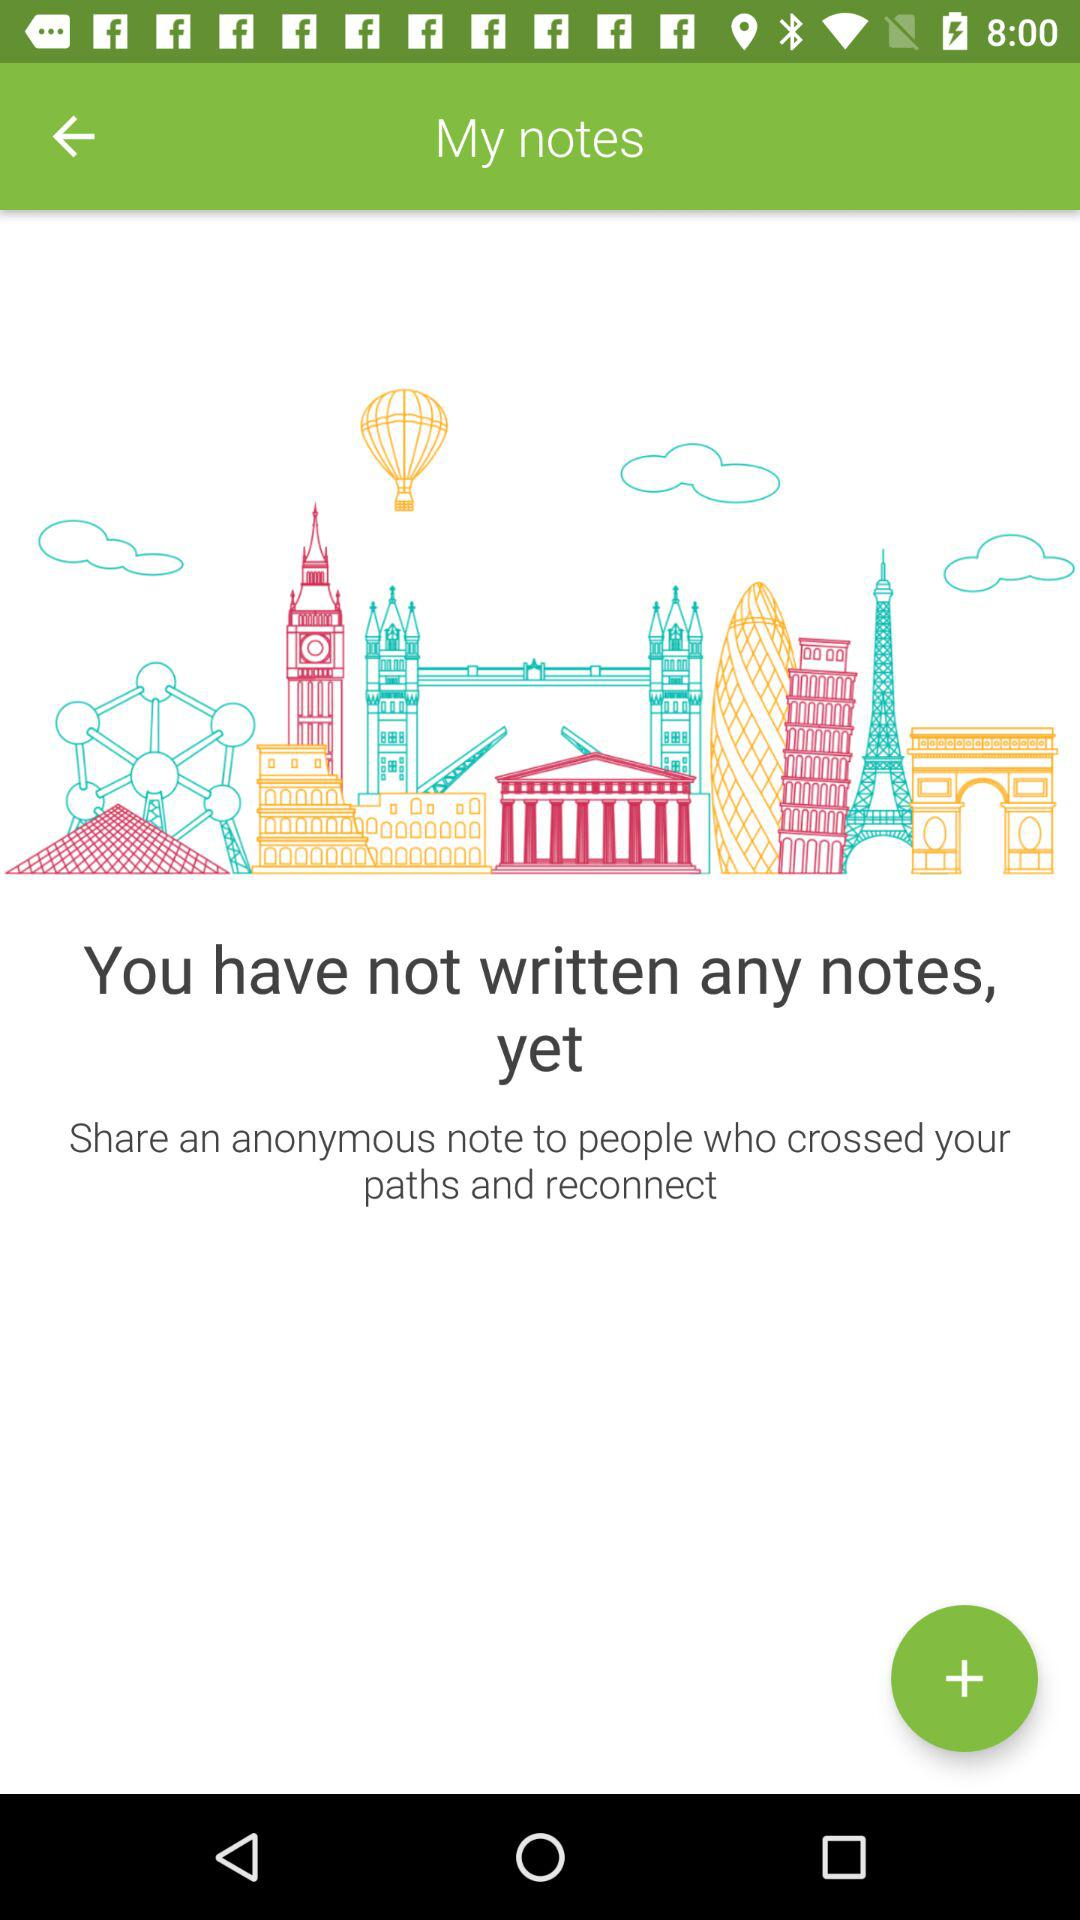Are there any written notes? There are no written notes. 